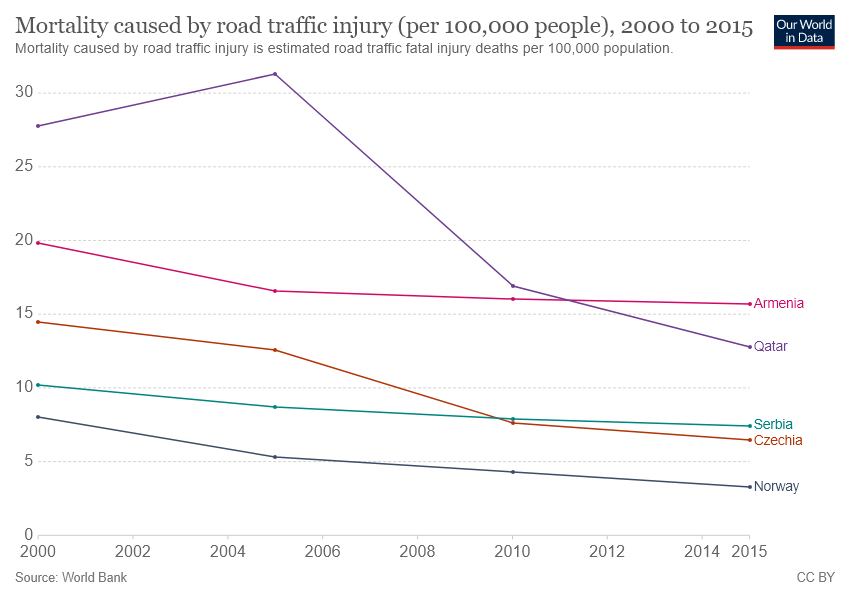Mention a couple of crucial points in this snapshot. The line representing Armenia and Qatar crosses each other at the point represented by the numeral one. Armenia is represented by the pink color line in the flag of Armenia. 